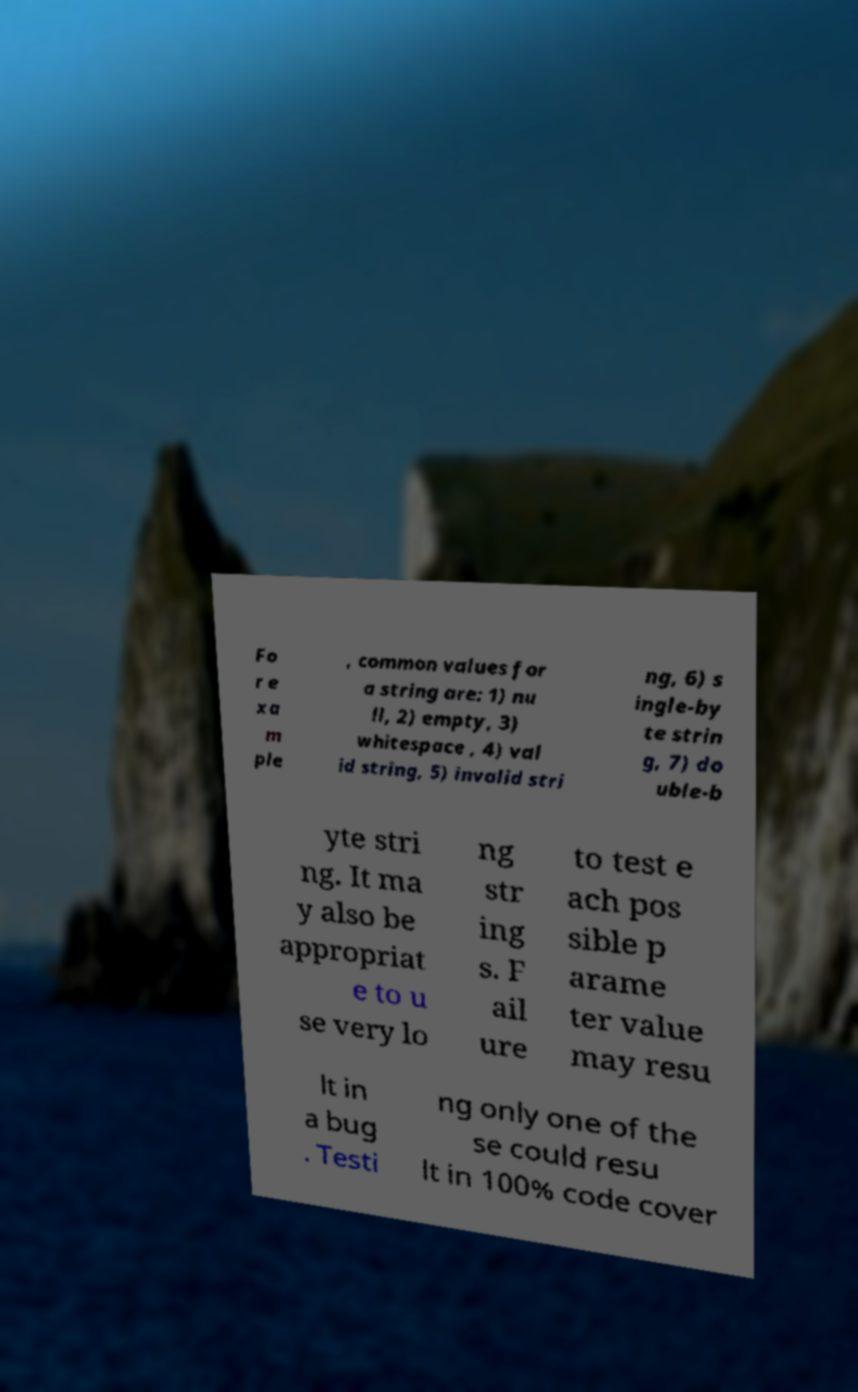Please read and relay the text visible in this image. What does it say? Fo r e xa m ple , common values for a string are: 1) nu ll, 2) empty, 3) whitespace , 4) val id string, 5) invalid stri ng, 6) s ingle-by te strin g, 7) do uble-b yte stri ng. It ma y also be appropriat e to u se very lo ng str ing s. F ail ure to test e ach pos sible p arame ter value may resu lt in a bug . Testi ng only one of the se could resu lt in 100% code cover 